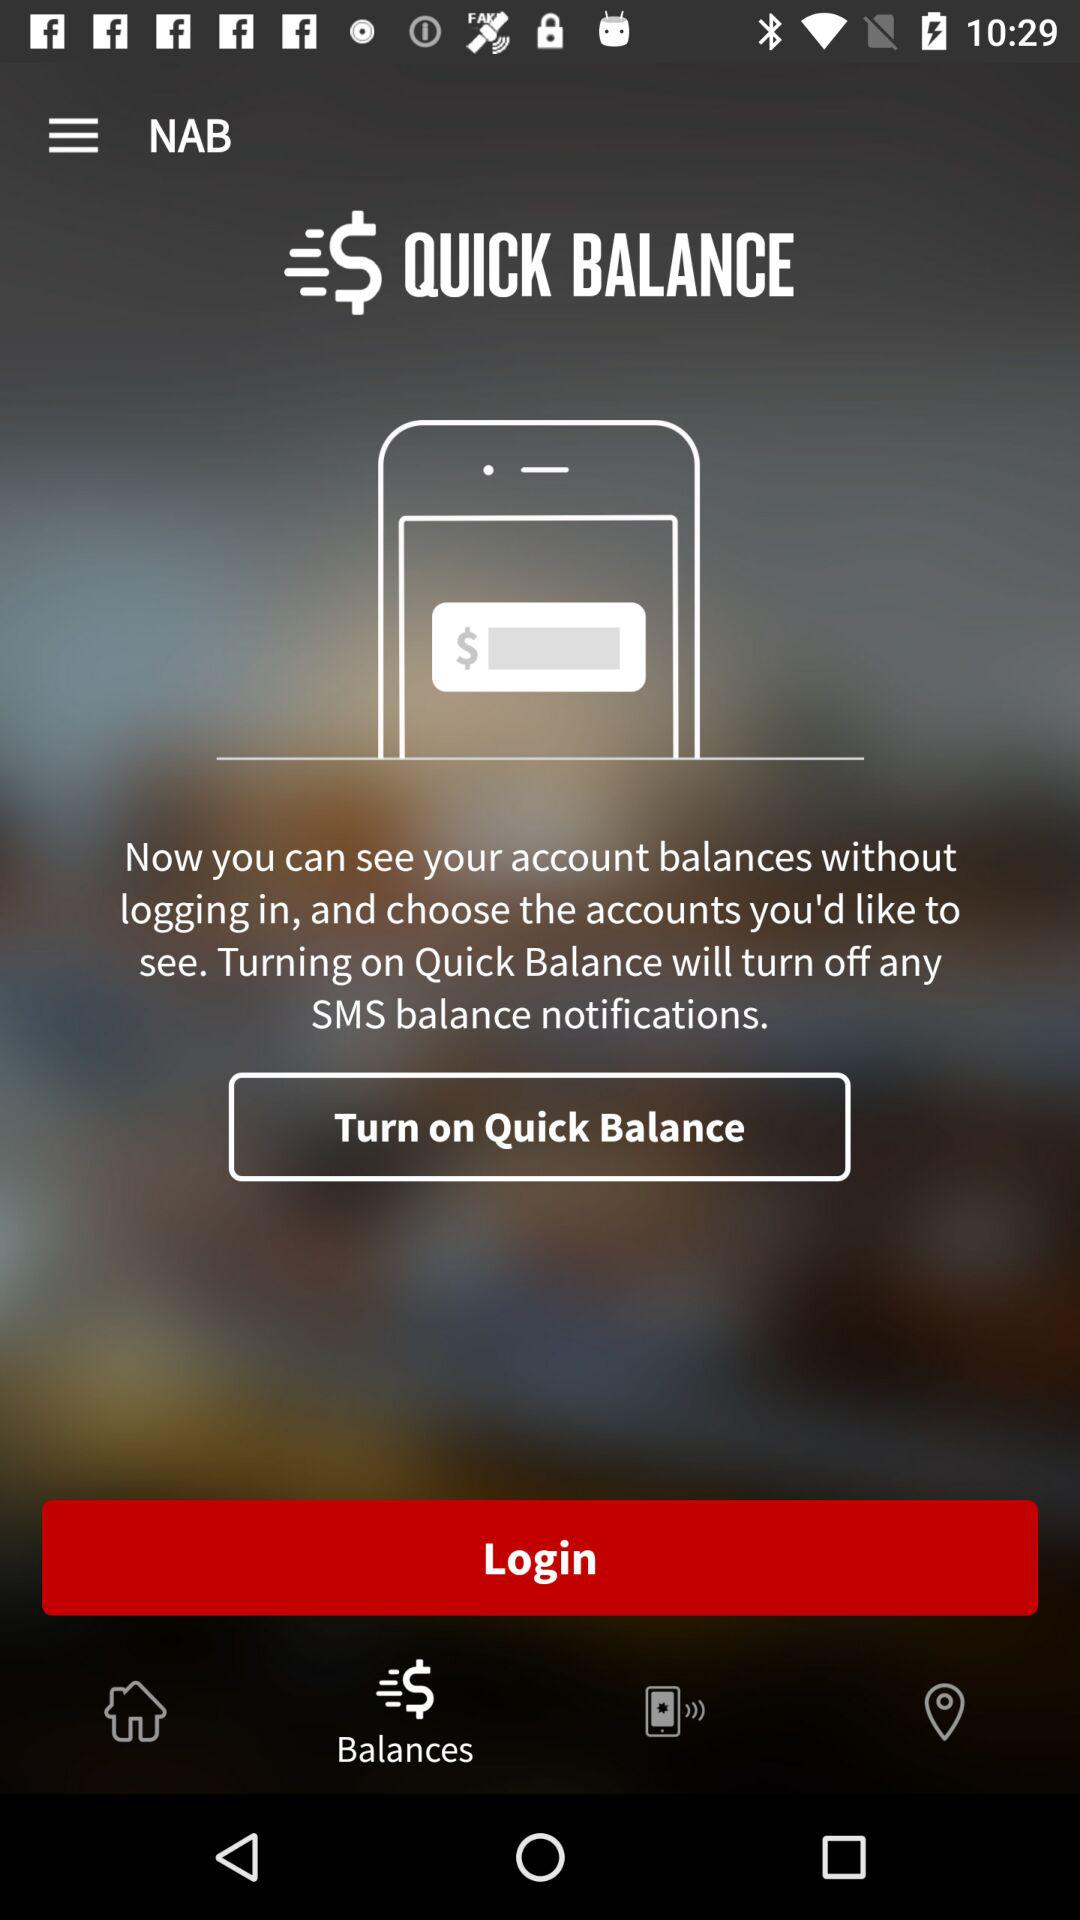How many notifications are there in "Balances"?
When the provided information is insufficient, respond with <no answer>. <no answer> 